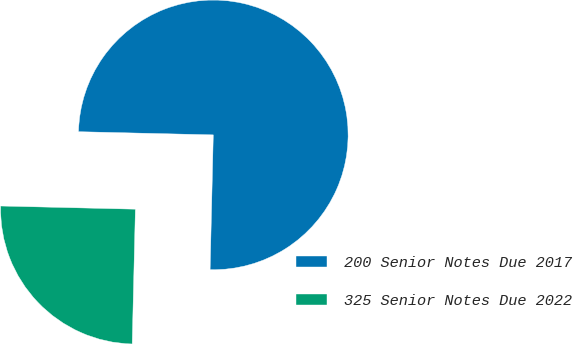Convert chart to OTSL. <chart><loc_0><loc_0><loc_500><loc_500><pie_chart><fcel>200 Senior Notes Due 2017<fcel>325 Senior Notes Due 2022<nl><fcel>75.0%<fcel>25.0%<nl></chart> 